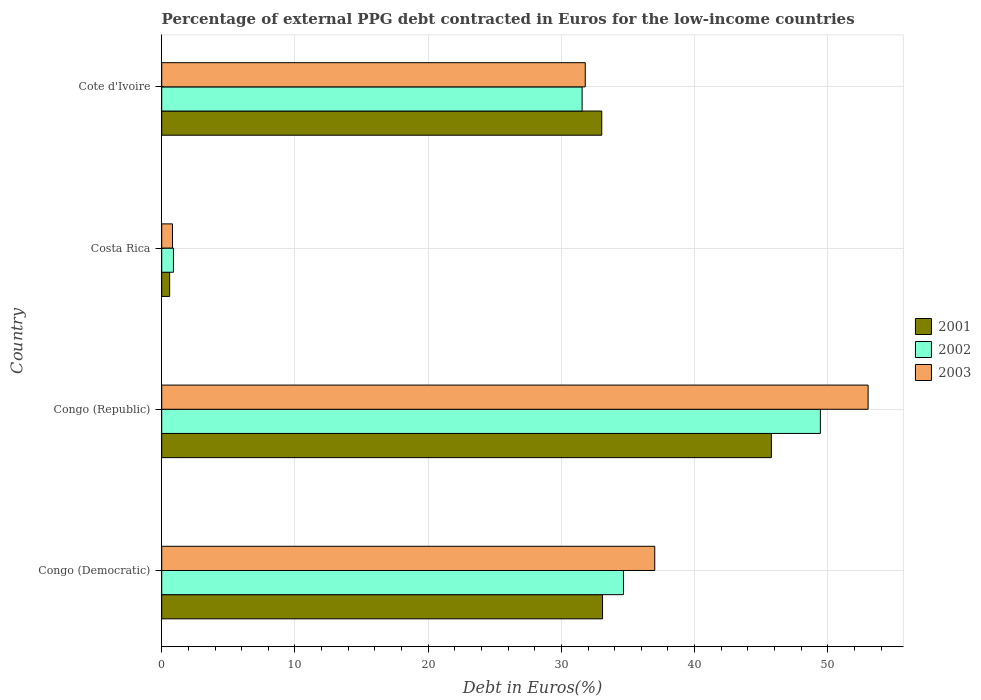What is the label of the 1st group of bars from the top?
Your response must be concise. Cote d'Ivoire. What is the percentage of external PPG debt contracted in Euros in 2003 in Cote d'Ivoire?
Your answer should be compact. 31.79. Across all countries, what is the maximum percentage of external PPG debt contracted in Euros in 2002?
Offer a very short reply. 49.44. Across all countries, what is the minimum percentage of external PPG debt contracted in Euros in 2001?
Offer a terse response. 0.6. In which country was the percentage of external PPG debt contracted in Euros in 2002 maximum?
Provide a succinct answer. Congo (Republic). In which country was the percentage of external PPG debt contracted in Euros in 2001 minimum?
Your response must be concise. Costa Rica. What is the total percentage of external PPG debt contracted in Euros in 2003 in the graph?
Offer a very short reply. 122.64. What is the difference between the percentage of external PPG debt contracted in Euros in 2001 in Congo (Democratic) and that in Cote d'Ivoire?
Offer a terse response. 0.06. What is the difference between the percentage of external PPG debt contracted in Euros in 2003 in Cote d'Ivoire and the percentage of external PPG debt contracted in Euros in 2001 in Congo (Democratic)?
Your answer should be compact. -1.3. What is the average percentage of external PPG debt contracted in Euros in 2001 per country?
Offer a terse response. 28.12. What is the difference between the percentage of external PPG debt contracted in Euros in 2003 and percentage of external PPG debt contracted in Euros in 2001 in Congo (Democratic)?
Your answer should be very brief. 3.92. In how many countries, is the percentage of external PPG debt contracted in Euros in 2001 greater than 2 %?
Your answer should be compact. 3. What is the ratio of the percentage of external PPG debt contracted in Euros in 2001 in Congo (Democratic) to that in Costa Rica?
Your answer should be very brief. 55.58. What is the difference between the highest and the second highest percentage of external PPG debt contracted in Euros in 2003?
Provide a succinct answer. 16.02. What is the difference between the highest and the lowest percentage of external PPG debt contracted in Euros in 2002?
Ensure brevity in your answer.  48.56. Is the sum of the percentage of external PPG debt contracted in Euros in 2002 in Congo (Republic) and Cote d'Ivoire greater than the maximum percentage of external PPG debt contracted in Euros in 2001 across all countries?
Ensure brevity in your answer.  Yes. What does the 3rd bar from the bottom in Congo (Democratic) represents?
Make the answer very short. 2003. Is it the case that in every country, the sum of the percentage of external PPG debt contracted in Euros in 2001 and percentage of external PPG debt contracted in Euros in 2003 is greater than the percentage of external PPG debt contracted in Euros in 2002?
Give a very brief answer. Yes. How many bars are there?
Offer a very short reply. 12. Are the values on the major ticks of X-axis written in scientific E-notation?
Offer a very short reply. No. Does the graph contain grids?
Ensure brevity in your answer.  Yes. Where does the legend appear in the graph?
Your answer should be compact. Center right. How are the legend labels stacked?
Your answer should be very brief. Vertical. What is the title of the graph?
Keep it short and to the point. Percentage of external PPG debt contracted in Euros for the low-income countries. Does "1978" appear as one of the legend labels in the graph?
Make the answer very short. No. What is the label or title of the X-axis?
Your answer should be compact. Debt in Euros(%). What is the Debt in Euros(%) in 2001 in Congo (Democratic)?
Ensure brevity in your answer.  33.09. What is the Debt in Euros(%) in 2002 in Congo (Democratic)?
Ensure brevity in your answer.  34.66. What is the Debt in Euros(%) of 2003 in Congo (Democratic)?
Keep it short and to the point. 37.01. What is the Debt in Euros(%) in 2001 in Congo (Republic)?
Offer a terse response. 45.76. What is the Debt in Euros(%) in 2002 in Congo (Republic)?
Give a very brief answer. 49.44. What is the Debt in Euros(%) in 2003 in Congo (Republic)?
Make the answer very short. 53.02. What is the Debt in Euros(%) in 2001 in Costa Rica?
Provide a short and direct response. 0.6. What is the Debt in Euros(%) of 2003 in Costa Rica?
Keep it short and to the point. 0.81. What is the Debt in Euros(%) of 2001 in Cote d'Ivoire?
Ensure brevity in your answer.  33.03. What is the Debt in Euros(%) in 2002 in Cote d'Ivoire?
Your answer should be compact. 31.56. What is the Debt in Euros(%) of 2003 in Cote d'Ivoire?
Offer a terse response. 31.79. Across all countries, what is the maximum Debt in Euros(%) of 2001?
Keep it short and to the point. 45.76. Across all countries, what is the maximum Debt in Euros(%) in 2002?
Ensure brevity in your answer.  49.44. Across all countries, what is the maximum Debt in Euros(%) of 2003?
Give a very brief answer. 53.02. Across all countries, what is the minimum Debt in Euros(%) in 2001?
Provide a short and direct response. 0.6. Across all countries, what is the minimum Debt in Euros(%) in 2003?
Provide a short and direct response. 0.81. What is the total Debt in Euros(%) in 2001 in the graph?
Your response must be concise. 112.48. What is the total Debt in Euros(%) of 2002 in the graph?
Provide a short and direct response. 116.54. What is the total Debt in Euros(%) in 2003 in the graph?
Keep it short and to the point. 122.64. What is the difference between the Debt in Euros(%) in 2001 in Congo (Democratic) and that in Congo (Republic)?
Make the answer very short. -12.67. What is the difference between the Debt in Euros(%) in 2002 in Congo (Democratic) and that in Congo (Republic)?
Your response must be concise. -14.78. What is the difference between the Debt in Euros(%) in 2003 in Congo (Democratic) and that in Congo (Republic)?
Make the answer very short. -16.02. What is the difference between the Debt in Euros(%) of 2001 in Congo (Democratic) and that in Costa Rica?
Give a very brief answer. 32.5. What is the difference between the Debt in Euros(%) in 2002 in Congo (Democratic) and that in Costa Rica?
Your answer should be compact. 33.78. What is the difference between the Debt in Euros(%) of 2003 in Congo (Democratic) and that in Costa Rica?
Keep it short and to the point. 36.2. What is the difference between the Debt in Euros(%) of 2001 in Congo (Democratic) and that in Cote d'Ivoire?
Your answer should be compact. 0.06. What is the difference between the Debt in Euros(%) of 2002 in Congo (Democratic) and that in Cote d'Ivoire?
Give a very brief answer. 3.1. What is the difference between the Debt in Euros(%) of 2003 in Congo (Democratic) and that in Cote d'Ivoire?
Offer a terse response. 5.22. What is the difference between the Debt in Euros(%) in 2001 in Congo (Republic) and that in Costa Rica?
Your answer should be compact. 45.17. What is the difference between the Debt in Euros(%) of 2002 in Congo (Republic) and that in Costa Rica?
Make the answer very short. 48.56. What is the difference between the Debt in Euros(%) of 2003 in Congo (Republic) and that in Costa Rica?
Offer a very short reply. 52.22. What is the difference between the Debt in Euros(%) of 2001 in Congo (Republic) and that in Cote d'Ivoire?
Provide a succinct answer. 12.73. What is the difference between the Debt in Euros(%) of 2002 in Congo (Republic) and that in Cote d'Ivoire?
Provide a succinct answer. 17.88. What is the difference between the Debt in Euros(%) in 2003 in Congo (Republic) and that in Cote d'Ivoire?
Your answer should be compact. 21.23. What is the difference between the Debt in Euros(%) in 2001 in Costa Rica and that in Cote d'Ivoire?
Your response must be concise. -32.44. What is the difference between the Debt in Euros(%) of 2002 in Costa Rica and that in Cote d'Ivoire?
Offer a very short reply. -30.68. What is the difference between the Debt in Euros(%) of 2003 in Costa Rica and that in Cote d'Ivoire?
Offer a very short reply. -30.98. What is the difference between the Debt in Euros(%) in 2001 in Congo (Democratic) and the Debt in Euros(%) in 2002 in Congo (Republic)?
Offer a terse response. -16.35. What is the difference between the Debt in Euros(%) of 2001 in Congo (Democratic) and the Debt in Euros(%) of 2003 in Congo (Republic)?
Make the answer very short. -19.93. What is the difference between the Debt in Euros(%) in 2002 in Congo (Democratic) and the Debt in Euros(%) in 2003 in Congo (Republic)?
Offer a terse response. -18.36. What is the difference between the Debt in Euros(%) of 2001 in Congo (Democratic) and the Debt in Euros(%) of 2002 in Costa Rica?
Offer a terse response. 32.21. What is the difference between the Debt in Euros(%) in 2001 in Congo (Democratic) and the Debt in Euros(%) in 2003 in Costa Rica?
Offer a terse response. 32.28. What is the difference between the Debt in Euros(%) of 2002 in Congo (Democratic) and the Debt in Euros(%) of 2003 in Costa Rica?
Make the answer very short. 33.85. What is the difference between the Debt in Euros(%) of 2001 in Congo (Democratic) and the Debt in Euros(%) of 2002 in Cote d'Ivoire?
Provide a succinct answer. 1.53. What is the difference between the Debt in Euros(%) of 2001 in Congo (Democratic) and the Debt in Euros(%) of 2003 in Cote d'Ivoire?
Keep it short and to the point. 1.3. What is the difference between the Debt in Euros(%) of 2002 in Congo (Democratic) and the Debt in Euros(%) of 2003 in Cote d'Ivoire?
Ensure brevity in your answer.  2.87. What is the difference between the Debt in Euros(%) of 2001 in Congo (Republic) and the Debt in Euros(%) of 2002 in Costa Rica?
Keep it short and to the point. 44.88. What is the difference between the Debt in Euros(%) in 2001 in Congo (Republic) and the Debt in Euros(%) in 2003 in Costa Rica?
Keep it short and to the point. 44.95. What is the difference between the Debt in Euros(%) of 2002 in Congo (Republic) and the Debt in Euros(%) of 2003 in Costa Rica?
Ensure brevity in your answer.  48.63. What is the difference between the Debt in Euros(%) of 2001 in Congo (Republic) and the Debt in Euros(%) of 2002 in Cote d'Ivoire?
Provide a succinct answer. 14.21. What is the difference between the Debt in Euros(%) in 2001 in Congo (Republic) and the Debt in Euros(%) in 2003 in Cote d'Ivoire?
Keep it short and to the point. 13.97. What is the difference between the Debt in Euros(%) of 2002 in Congo (Republic) and the Debt in Euros(%) of 2003 in Cote d'Ivoire?
Your answer should be very brief. 17.65. What is the difference between the Debt in Euros(%) of 2001 in Costa Rica and the Debt in Euros(%) of 2002 in Cote d'Ivoire?
Your response must be concise. -30.96. What is the difference between the Debt in Euros(%) in 2001 in Costa Rica and the Debt in Euros(%) in 2003 in Cote d'Ivoire?
Ensure brevity in your answer.  -31.2. What is the difference between the Debt in Euros(%) of 2002 in Costa Rica and the Debt in Euros(%) of 2003 in Cote d'Ivoire?
Provide a short and direct response. -30.91. What is the average Debt in Euros(%) of 2001 per country?
Provide a short and direct response. 28.12. What is the average Debt in Euros(%) of 2002 per country?
Provide a succinct answer. 29.14. What is the average Debt in Euros(%) of 2003 per country?
Keep it short and to the point. 30.66. What is the difference between the Debt in Euros(%) in 2001 and Debt in Euros(%) in 2002 in Congo (Democratic)?
Your answer should be very brief. -1.57. What is the difference between the Debt in Euros(%) of 2001 and Debt in Euros(%) of 2003 in Congo (Democratic)?
Give a very brief answer. -3.92. What is the difference between the Debt in Euros(%) of 2002 and Debt in Euros(%) of 2003 in Congo (Democratic)?
Make the answer very short. -2.35. What is the difference between the Debt in Euros(%) in 2001 and Debt in Euros(%) in 2002 in Congo (Republic)?
Offer a terse response. -3.68. What is the difference between the Debt in Euros(%) in 2001 and Debt in Euros(%) in 2003 in Congo (Republic)?
Your response must be concise. -7.26. What is the difference between the Debt in Euros(%) in 2002 and Debt in Euros(%) in 2003 in Congo (Republic)?
Provide a short and direct response. -3.58. What is the difference between the Debt in Euros(%) of 2001 and Debt in Euros(%) of 2002 in Costa Rica?
Offer a very short reply. -0.28. What is the difference between the Debt in Euros(%) in 2001 and Debt in Euros(%) in 2003 in Costa Rica?
Provide a succinct answer. -0.21. What is the difference between the Debt in Euros(%) in 2002 and Debt in Euros(%) in 2003 in Costa Rica?
Ensure brevity in your answer.  0.07. What is the difference between the Debt in Euros(%) in 2001 and Debt in Euros(%) in 2002 in Cote d'Ivoire?
Offer a very short reply. 1.47. What is the difference between the Debt in Euros(%) of 2001 and Debt in Euros(%) of 2003 in Cote d'Ivoire?
Provide a succinct answer. 1.24. What is the difference between the Debt in Euros(%) in 2002 and Debt in Euros(%) in 2003 in Cote d'Ivoire?
Provide a succinct answer. -0.23. What is the ratio of the Debt in Euros(%) in 2001 in Congo (Democratic) to that in Congo (Republic)?
Make the answer very short. 0.72. What is the ratio of the Debt in Euros(%) in 2002 in Congo (Democratic) to that in Congo (Republic)?
Give a very brief answer. 0.7. What is the ratio of the Debt in Euros(%) of 2003 in Congo (Democratic) to that in Congo (Republic)?
Give a very brief answer. 0.7. What is the ratio of the Debt in Euros(%) in 2001 in Congo (Democratic) to that in Costa Rica?
Offer a terse response. 55.58. What is the ratio of the Debt in Euros(%) of 2002 in Congo (Democratic) to that in Costa Rica?
Your response must be concise. 39.39. What is the ratio of the Debt in Euros(%) of 2003 in Congo (Democratic) to that in Costa Rica?
Your answer should be compact. 45.76. What is the ratio of the Debt in Euros(%) of 2001 in Congo (Democratic) to that in Cote d'Ivoire?
Keep it short and to the point. 1. What is the ratio of the Debt in Euros(%) of 2002 in Congo (Democratic) to that in Cote d'Ivoire?
Offer a terse response. 1.1. What is the ratio of the Debt in Euros(%) of 2003 in Congo (Democratic) to that in Cote d'Ivoire?
Your response must be concise. 1.16. What is the ratio of the Debt in Euros(%) of 2001 in Congo (Republic) to that in Costa Rica?
Keep it short and to the point. 76.86. What is the ratio of the Debt in Euros(%) of 2002 in Congo (Republic) to that in Costa Rica?
Provide a succinct answer. 56.18. What is the ratio of the Debt in Euros(%) of 2003 in Congo (Republic) to that in Costa Rica?
Provide a succinct answer. 65.56. What is the ratio of the Debt in Euros(%) in 2001 in Congo (Republic) to that in Cote d'Ivoire?
Provide a short and direct response. 1.39. What is the ratio of the Debt in Euros(%) of 2002 in Congo (Republic) to that in Cote d'Ivoire?
Your answer should be compact. 1.57. What is the ratio of the Debt in Euros(%) of 2003 in Congo (Republic) to that in Cote d'Ivoire?
Your response must be concise. 1.67. What is the ratio of the Debt in Euros(%) of 2001 in Costa Rica to that in Cote d'Ivoire?
Provide a short and direct response. 0.02. What is the ratio of the Debt in Euros(%) of 2002 in Costa Rica to that in Cote d'Ivoire?
Provide a short and direct response. 0.03. What is the ratio of the Debt in Euros(%) in 2003 in Costa Rica to that in Cote d'Ivoire?
Offer a terse response. 0.03. What is the difference between the highest and the second highest Debt in Euros(%) of 2001?
Your answer should be compact. 12.67. What is the difference between the highest and the second highest Debt in Euros(%) in 2002?
Make the answer very short. 14.78. What is the difference between the highest and the second highest Debt in Euros(%) in 2003?
Ensure brevity in your answer.  16.02. What is the difference between the highest and the lowest Debt in Euros(%) in 2001?
Ensure brevity in your answer.  45.17. What is the difference between the highest and the lowest Debt in Euros(%) of 2002?
Offer a terse response. 48.56. What is the difference between the highest and the lowest Debt in Euros(%) of 2003?
Your answer should be very brief. 52.22. 